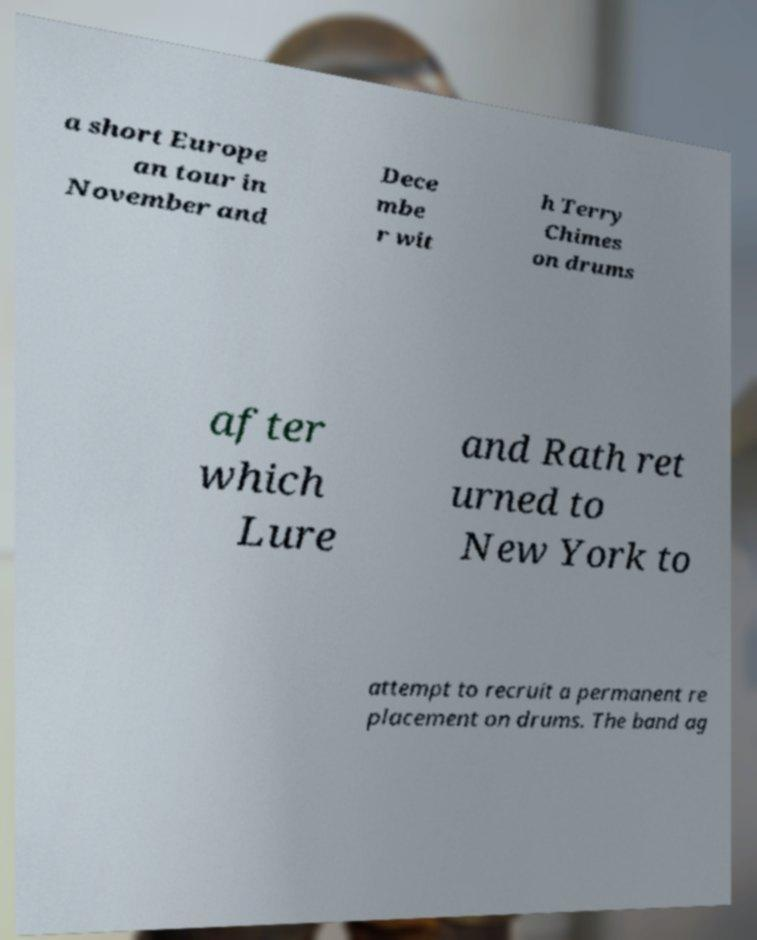Could you extract and type out the text from this image? a short Europe an tour in November and Dece mbe r wit h Terry Chimes on drums after which Lure and Rath ret urned to New York to attempt to recruit a permanent re placement on drums. The band ag 